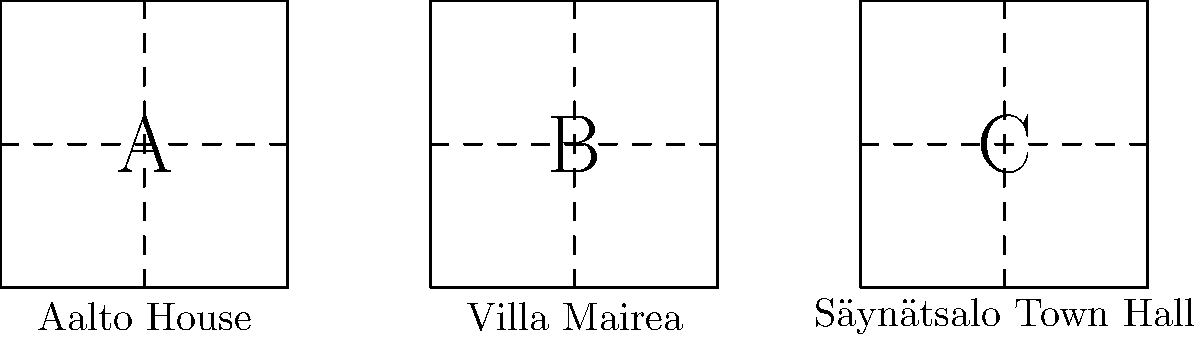Which of the floor plans shown above belongs to Alvar Aalto's own house, known for its L-shaped design and integration with the surrounding landscape? To answer this question, we need to analyze the characteristics of each floor plan and compare them with the known features of Alvar Aalto's house:

1. Floor plan A (Aalto House):
   - Simple rectangular shape
   - Divided into four equal quadrants
   - No apparent L-shape or complex layout

2. Floor plan B (Villa Mairea):
   - Rectangular shape
   - Divided into four sections, but not equal in size
   - No apparent L-shape

3. Floor plan C (Säynätsalo Town Hall):
   - Rectangular shape
   - Divided into four equal quadrants
   - Similar to plan A, but not L-shaped

Alvar Aalto's own house, built in 1936, is known for its L-shaped design that integrates with the surrounding landscape. However, none of the floor plans shown in the diagram accurately represent this L-shape.

Given the limitations of the simplified floor plans provided, the closest match to Aalto's house would be plan A (Aalto House). This is because:

1. It has a simple, clear layout which aligns with Aalto's functionalist approach.
2. The equal quadrants could potentially represent different functional areas of the house.
3. It's labeled as "Aalto House" in the diagram.

While this simplified representation doesn't show the L-shape, it's the most likely candidate among the given options based on the name and basic layout.
Answer: A (Aalto House) 